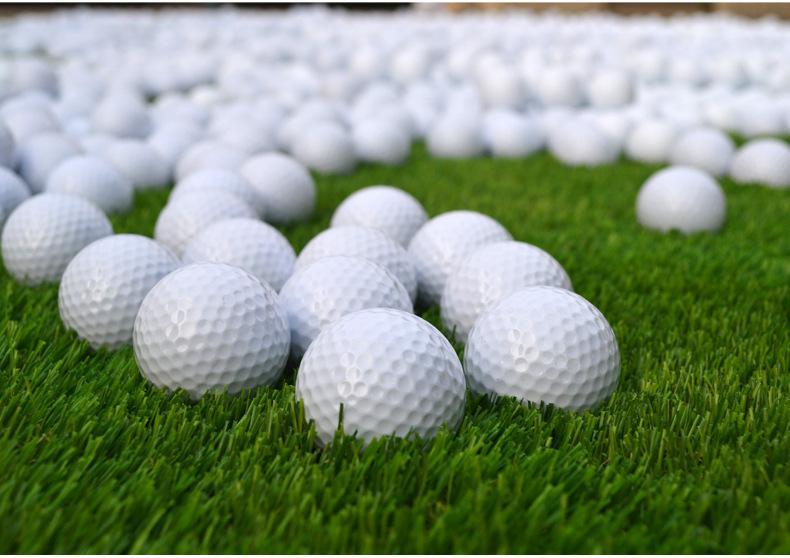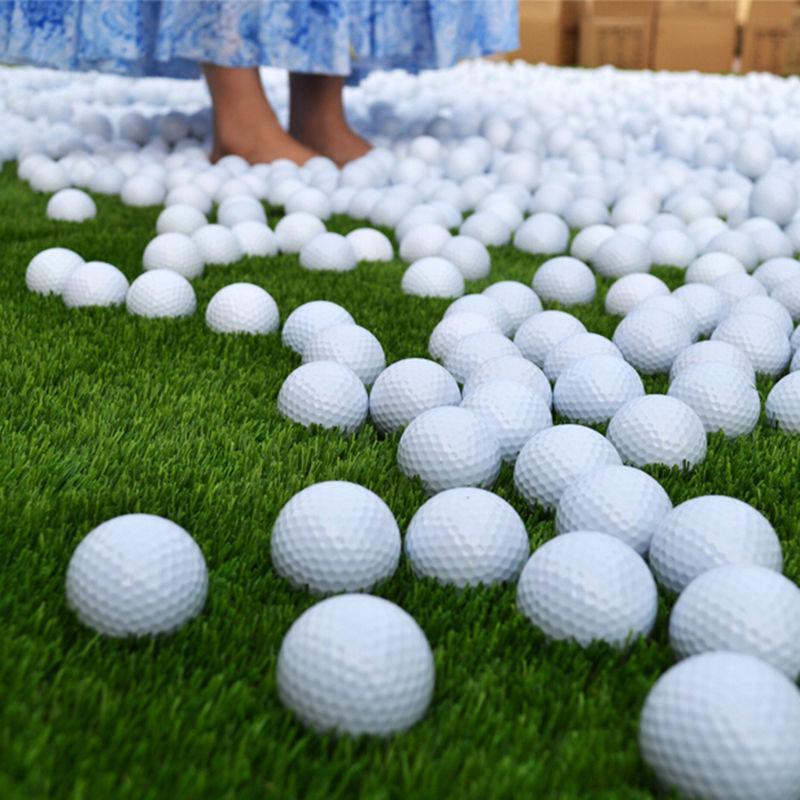The first image is the image on the left, the second image is the image on the right. Examine the images to the left and right. Is the description "An image shows golf balls in some type of square shape, on a grass type background." accurate? Answer yes or no. No. The first image is the image on the left, the second image is the image on the right. For the images shown, is this caption "Both images show golf balls on a grass-type background." true? Answer yes or no. Yes. The first image is the image on the left, the second image is the image on the right. Evaluate the accuracy of this statement regarding the images: "At least one of the images do not contain grass.". Is it true? Answer yes or no. No. The first image is the image on the left, the second image is the image on the right. Evaluate the accuracy of this statement regarding the images: "There is one golf ball sitting on top of other balls in the image on the right.". Is it true? Answer yes or no. No. 